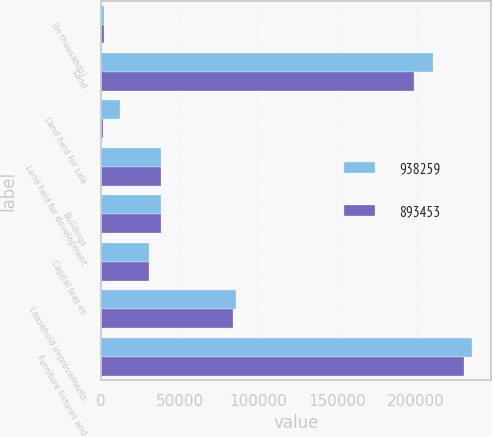Convert chart. <chart><loc_0><loc_0><loc_500><loc_500><stacked_bar_chart><ecel><fcel>(In thousands)<fcel>Land<fcel>Land held for sale<fcel>Land held for development<fcel>Buildings<fcel>Capital leas es<fcel>Leasehold improvements<fcel>Furniture fixtures and<nl><fcel>938259<fcel>2010<fcel>211132<fcel>11945<fcel>38464<fcel>38332<fcel>30640<fcel>85955<fcel>236194<nl><fcel>893453<fcel>2009<fcel>198809<fcel>1432<fcel>38200<fcel>38332<fcel>30640<fcel>83823<fcel>230552<nl></chart> 